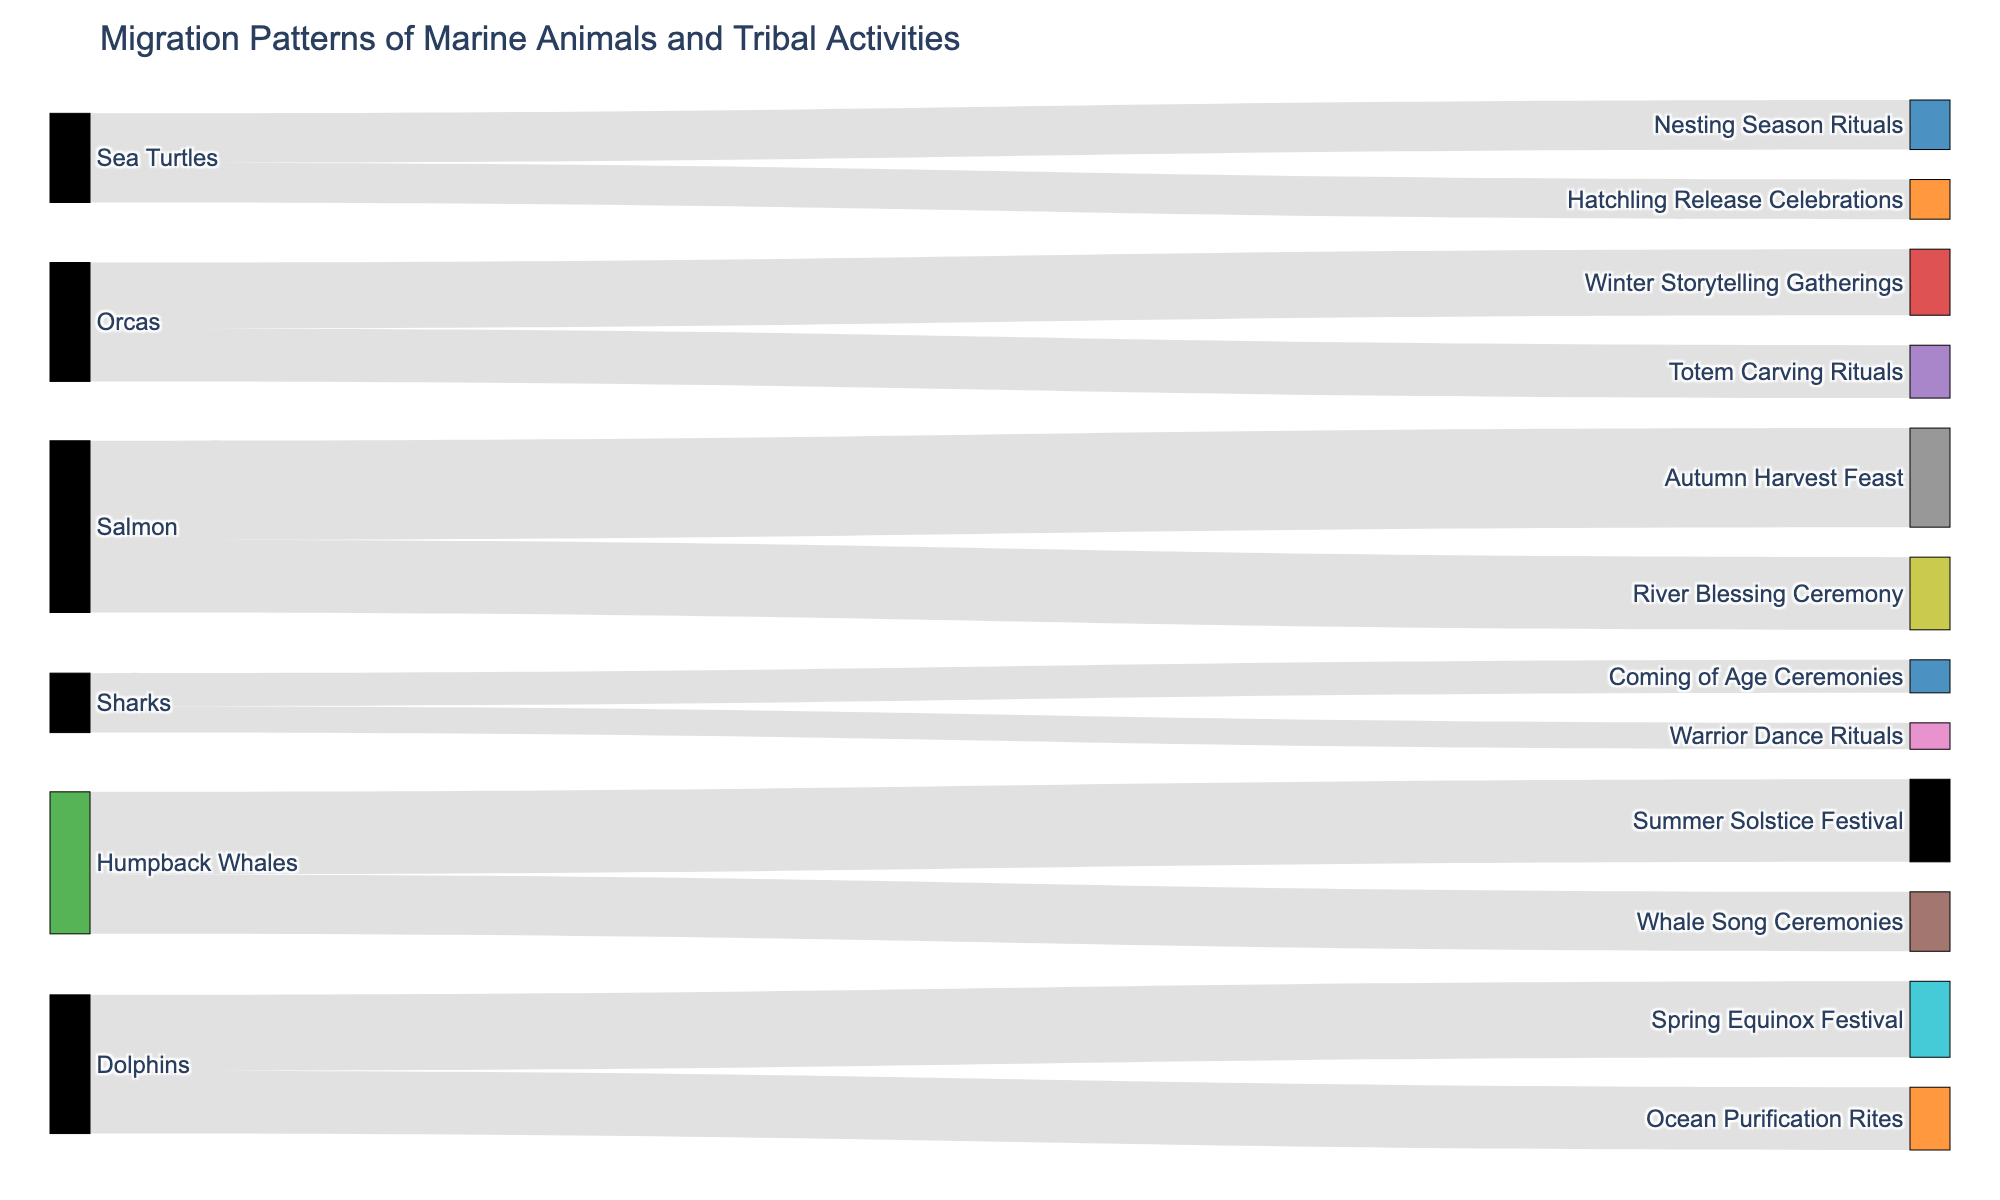What is the title of the figure? To find the title of the figure, look at the top part of the visualization where the text describing the main topic is usually placed.
Answer: Migration Patterns of Marine Animals and Tribal Activities Which marine animal is associated with the Summer Solstice Festival? Look at the connections between marine animals and tribal activities. Follow the link that leads to the Summer Solstice Festival.
Answer: Humpback Whales How many marine animals are linked to the River Blessing Ceremony? Identify the River Blessing Ceremony node and count the connections leading to it.
Answer: One (Salmon) Which tribal activity is linked to the highest value of marine animal migration? Observe the values associated with each link and identify the link with the highest value.
Answer: Autumn Harvest Feast What are the total migration values for Humpback Whales across all associated tribal activities? Identify all the values connected to the Humpback Whales and sum them up: 250 (Summer Solstice Festival) + 180 (Whale Song Ceremonies)
Answer: 430 Do more marine animals participate in festival-related activities compared to ceremonial ones? Count the number of connections between marine animals and festivals, then count those linked to ceremonies, and compare the two counts.
Answer: More marine animals are linked to ceremonies Which two marine animals are associated with the highest total migration value across their activities? Compute the total value for each marine animal across their linked activities and compare them to find the two highest.
Answer: Salmon and Humpback Whales What is the difference in migration values between the Orcas participating in Winter Storytelling Gatherings and Totem Carving Rituals? Identify the values for Orcas in Winter Storytelling Gatherings and Totem Carving Rituals, then subtract the smaller value from the larger one: 200 - 160
Answer: 40 Which marine animal has the most diverse range of tribal activities? Count the number of unique tribal activities linked to each marine animal and identify the one with the highest count.
Answer: Humpback Whales & Dolphins (same number of activities) How does the migration value of Dolphins in the Spring Equinox Festival compare to that in the Ocean Purification Rites? Look at the values for Dolphins in both the Spring Equinox Festival and Ocean Purification Rites and compare them.
Answer: Spring Equinox Festival has a higher value than Ocean Purification Rites 